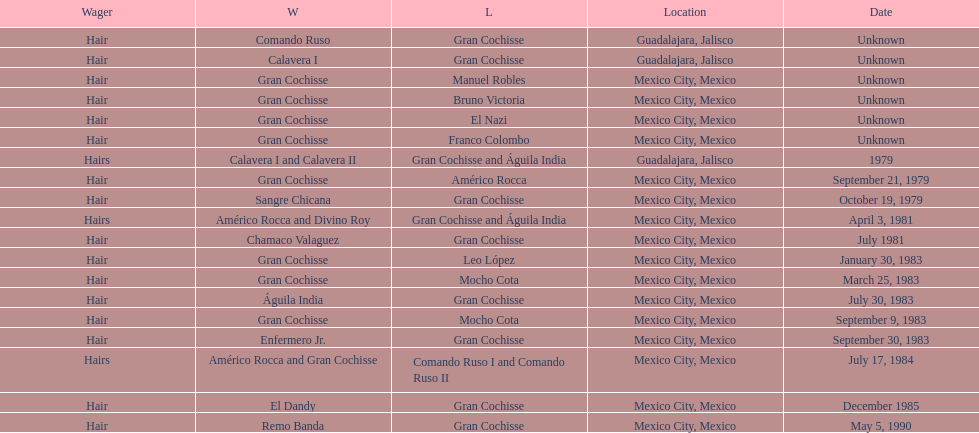What was the count of defeats gran cochisse experienced against el dandy? 1. 